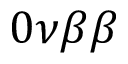Convert formula to latex. <formula><loc_0><loc_0><loc_500><loc_500>0 \nu \beta \beta</formula> 